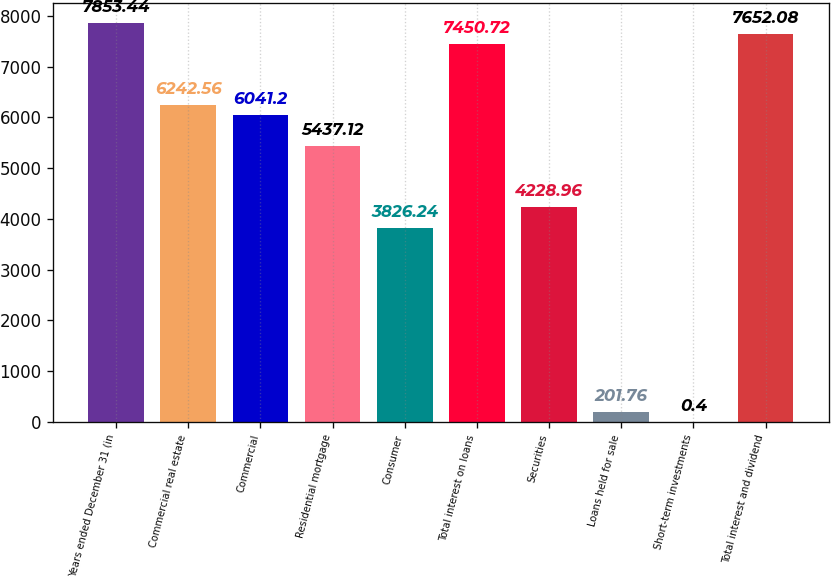Convert chart. <chart><loc_0><loc_0><loc_500><loc_500><bar_chart><fcel>Years ended December 31 (in<fcel>Commercial real estate<fcel>Commercial<fcel>Residential mortgage<fcel>Consumer<fcel>Total interest on loans<fcel>Securities<fcel>Loans held for sale<fcel>Short-term investments<fcel>Total interest and dividend<nl><fcel>7853.44<fcel>6242.56<fcel>6041.2<fcel>5437.12<fcel>3826.24<fcel>7450.72<fcel>4228.96<fcel>201.76<fcel>0.4<fcel>7652.08<nl></chart> 